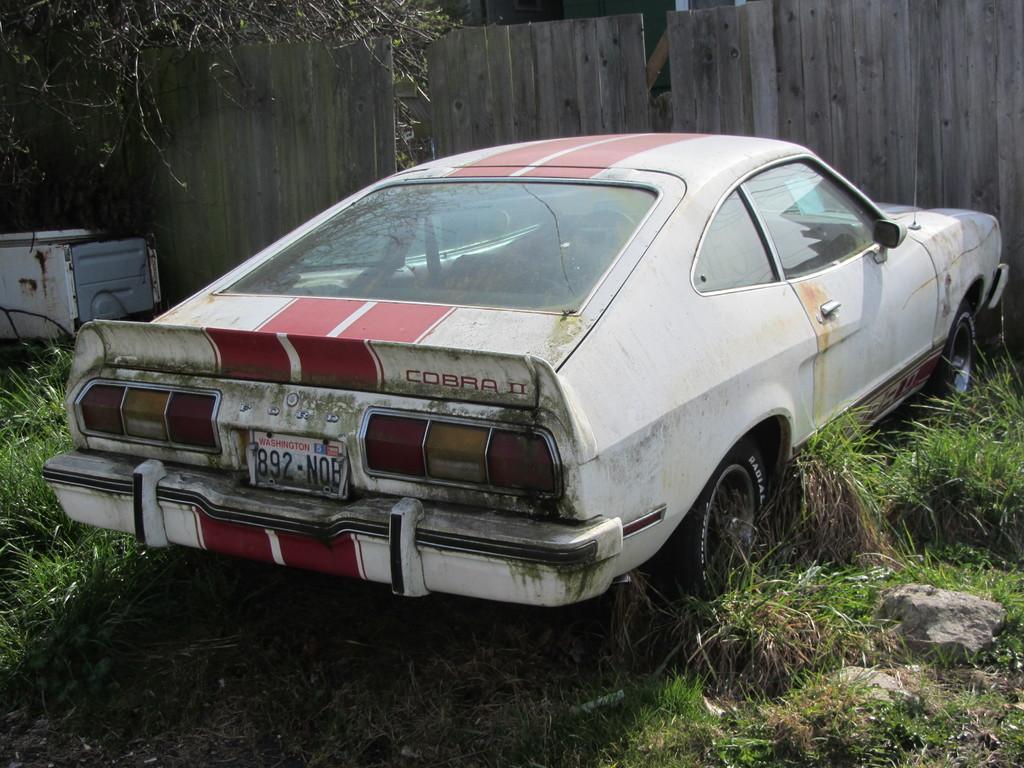Please provide a concise description of this image. In the picture I can see a car. In the background, I can see the wooden wall. I can see the white color container on the left side. I can see the green grass and rocks at the bottom of the image. 